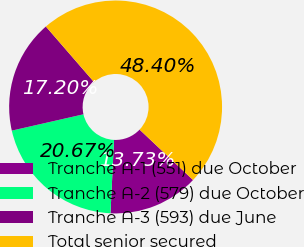<chart> <loc_0><loc_0><loc_500><loc_500><pie_chart><fcel>Tranche A-1 (551) due October<fcel>Tranche A-2 (579) due October<fcel>Tranche A-3 (593) due June<fcel>Total senior secured<nl><fcel>13.73%<fcel>20.67%<fcel>17.2%<fcel>48.4%<nl></chart> 